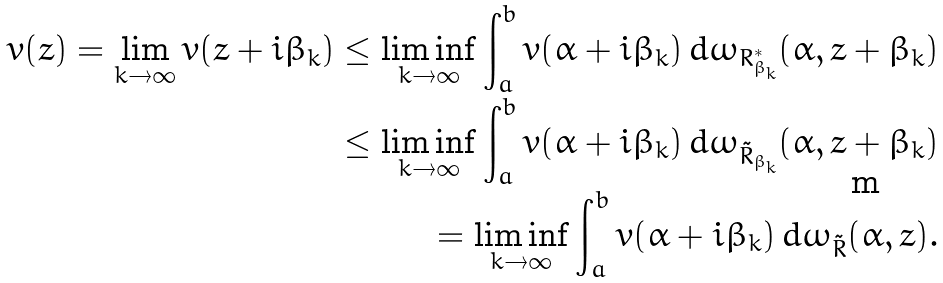Convert formula to latex. <formula><loc_0><loc_0><loc_500><loc_500>v ( z ) = \lim _ { k \to \infty } v ( z + i \beta _ { k } ) \leq \liminf _ { k \to \infty } \int _ { a } ^ { b } v ( \alpha + i \beta _ { k } ) \, d \omega _ { R ^ { * } _ { \beta _ { k } } } ( \alpha , z + \beta _ { k } ) \\ \leq \liminf _ { k \to \infty } \int _ { a } ^ { b } v ( \alpha + i \beta _ { k } ) \, d \omega _ { \tilde { R } _ { \beta _ { k } } } ( \alpha , z + \beta _ { k } ) \\ = \liminf _ { k \to \infty } \int _ { a } ^ { b } v ( \alpha + i \beta _ { k } ) \, d \omega _ { \tilde { R } } ( \alpha , z ) .</formula> 